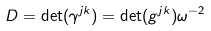Convert formula to latex. <formula><loc_0><loc_0><loc_500><loc_500>D = \det ( \gamma ^ { j k } ) = \det ( g ^ { j k } ) \omega ^ { - 2 }</formula> 